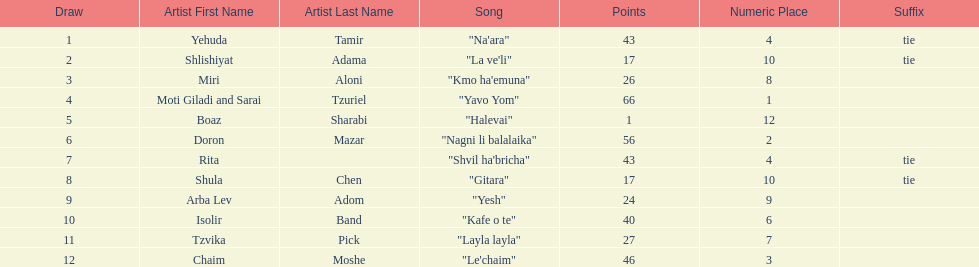What is the name of the song listed before the song "yesh"? "Gitara". 